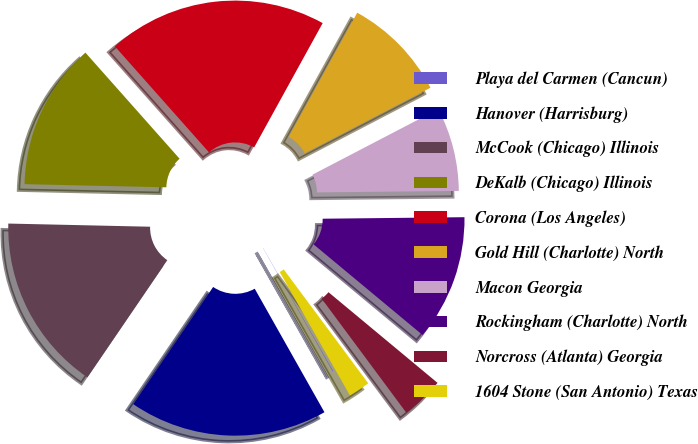Convert chart to OTSL. <chart><loc_0><loc_0><loc_500><loc_500><pie_chart><fcel>Playa del Carmen (Cancun)<fcel>Hanover (Harrisburg)<fcel>McCook (Chicago) Illinois<fcel>DeKalb (Chicago) Illinois<fcel>Corona (Los Angeles)<fcel>Gold Hill (Charlotte) North<fcel>Macon Georgia<fcel>Rockingham (Charlotte) North<fcel>Norcross (Atlanta) Georgia<fcel>1604 Stone (San Antonio) Texas<nl><fcel>0.05%<fcel>17.7%<fcel>15.83%<fcel>13.09%<fcel>19.57%<fcel>9.34%<fcel>7.47%<fcel>11.21%<fcel>3.8%<fcel>1.93%<nl></chart> 